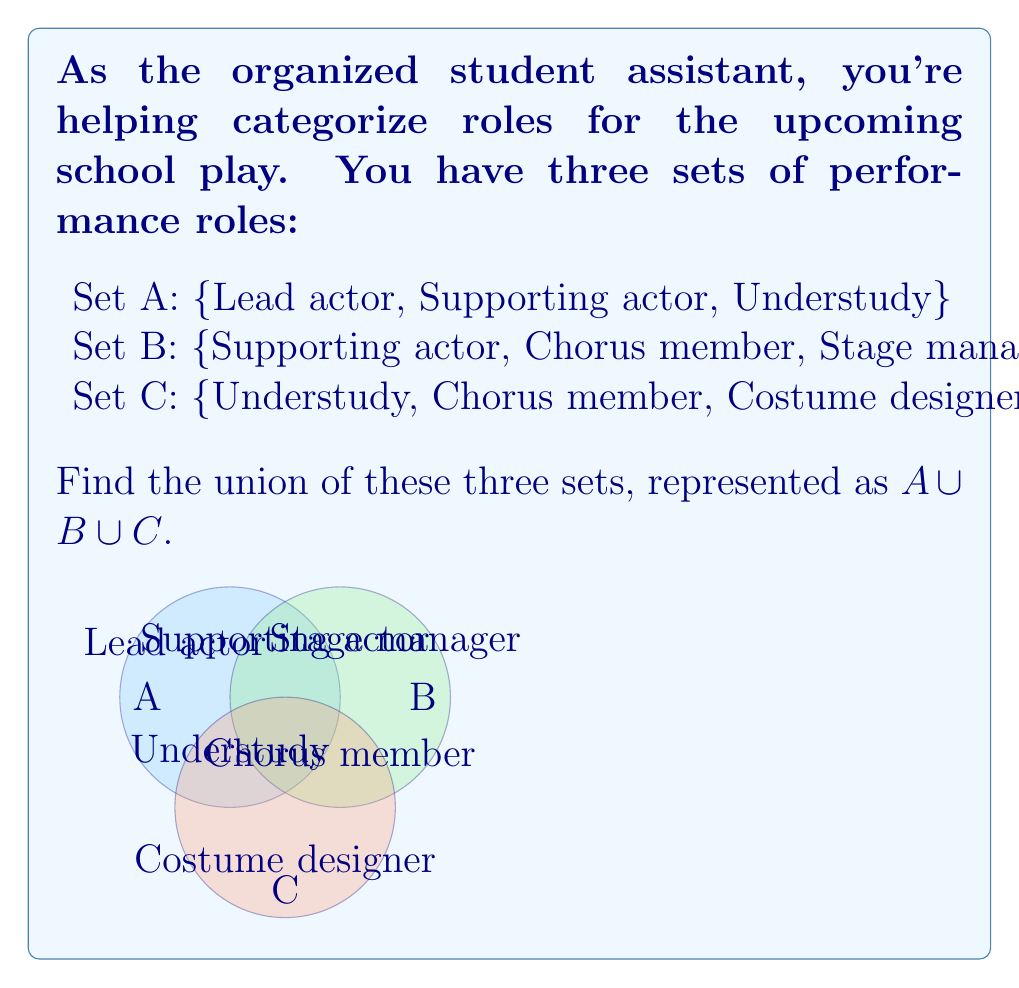Show me your answer to this math problem. To find the union of sets A, B, and C, we need to list all unique elements from all three sets. Let's follow these steps:

1. List all elements from set A:
   $A = \{$Lead actor, Supporting actor, Understudy$\}$

2. Add any new elements from set B:
   $B = \{$Supporting actor, Chorus member, Stage manager$\}$
   New elements: Chorus member, Stage manager

3. Add any new elements from set C:
   $C = \{$Understudy, Chorus member, Costume designer$\}$
   New element: Costume designer

4. Combine all unique elements:
   $A \cup B \cup C = \{$Lead actor, Supporting actor, Understudy, Chorus member, Stage manager, Costume designer$\}$

Note that we only list each element once, even if it appears in multiple sets. For example, "Supporting actor" appears in both A and B, but we only include it once in the union.
Answer: $\{$Lead actor, Supporting actor, Understudy, Chorus member, Stage manager, Costume designer$\}$ 